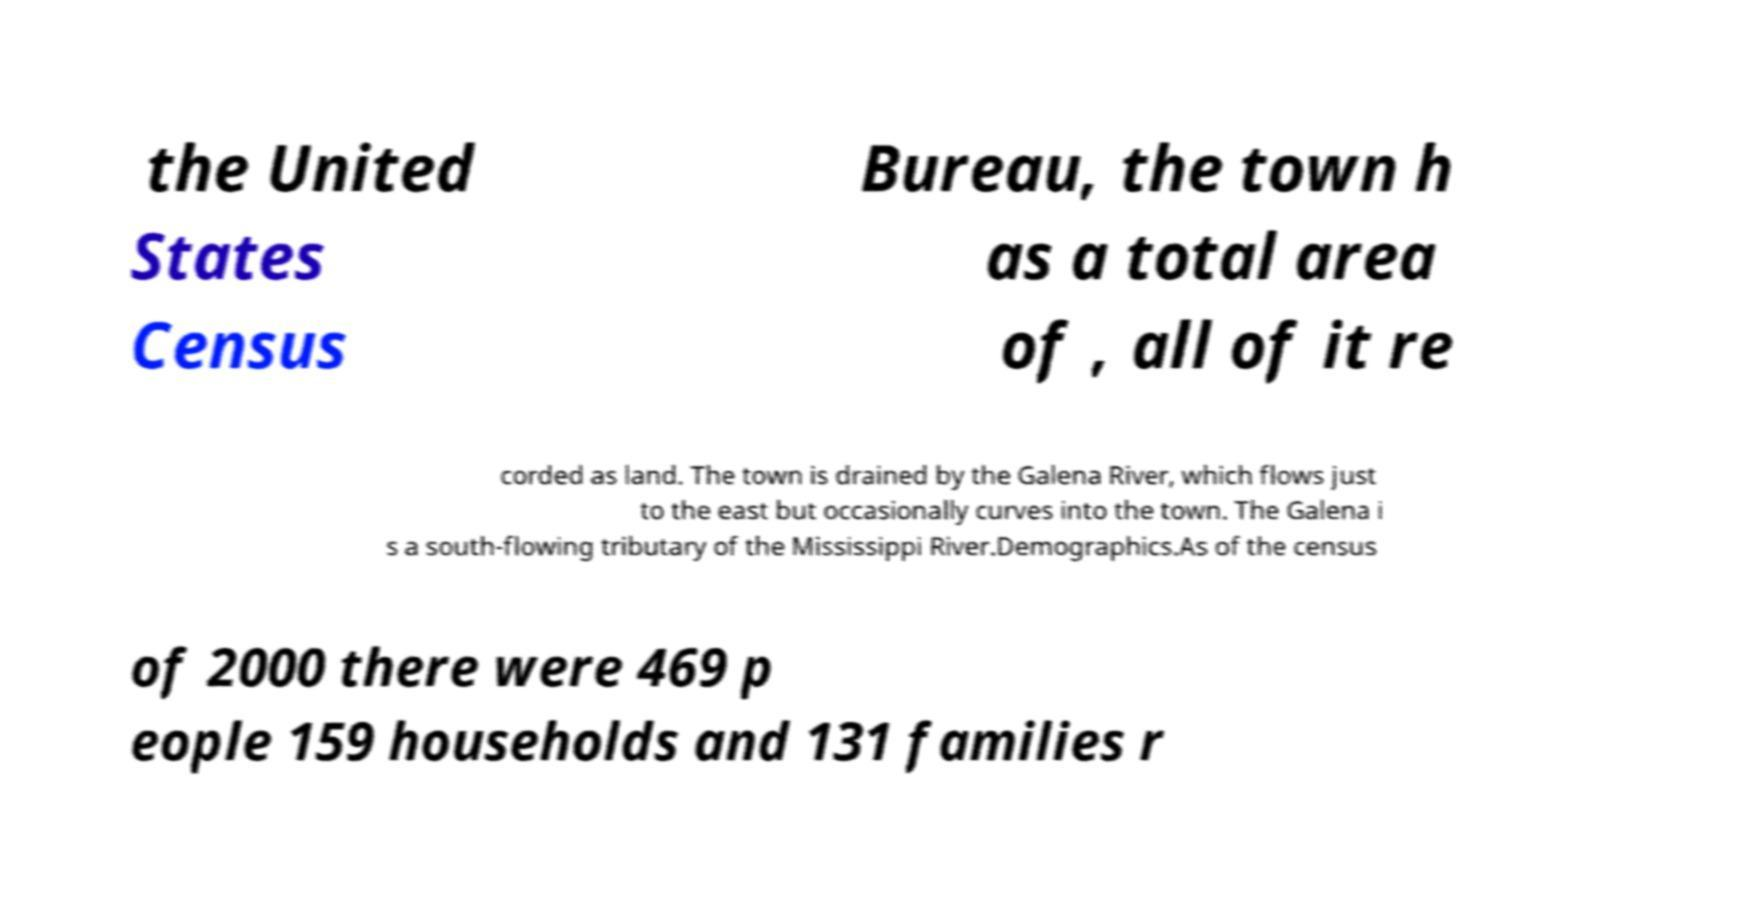For documentation purposes, I need the text within this image transcribed. Could you provide that? the United States Census Bureau, the town h as a total area of , all of it re corded as land. The town is drained by the Galena River, which flows just to the east but occasionally curves into the town. The Galena i s a south-flowing tributary of the Mississippi River.Demographics.As of the census of 2000 there were 469 p eople 159 households and 131 families r 